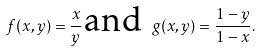Convert formula to latex. <formula><loc_0><loc_0><loc_500><loc_500>f ( x , y ) = \frac { x } { y } \, \text {and\ } g ( x , y ) = \frac { 1 - y } { 1 - x } .</formula> 